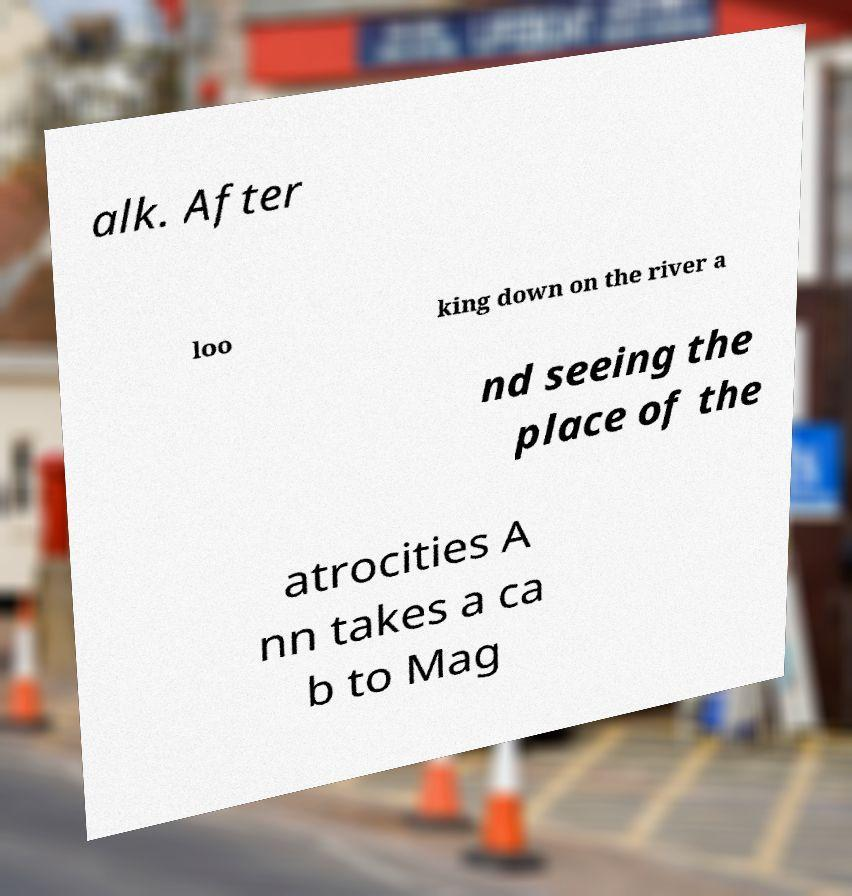There's text embedded in this image that I need extracted. Can you transcribe it verbatim? alk. After loo king down on the river a nd seeing the place of the atrocities A nn takes a ca b to Mag 